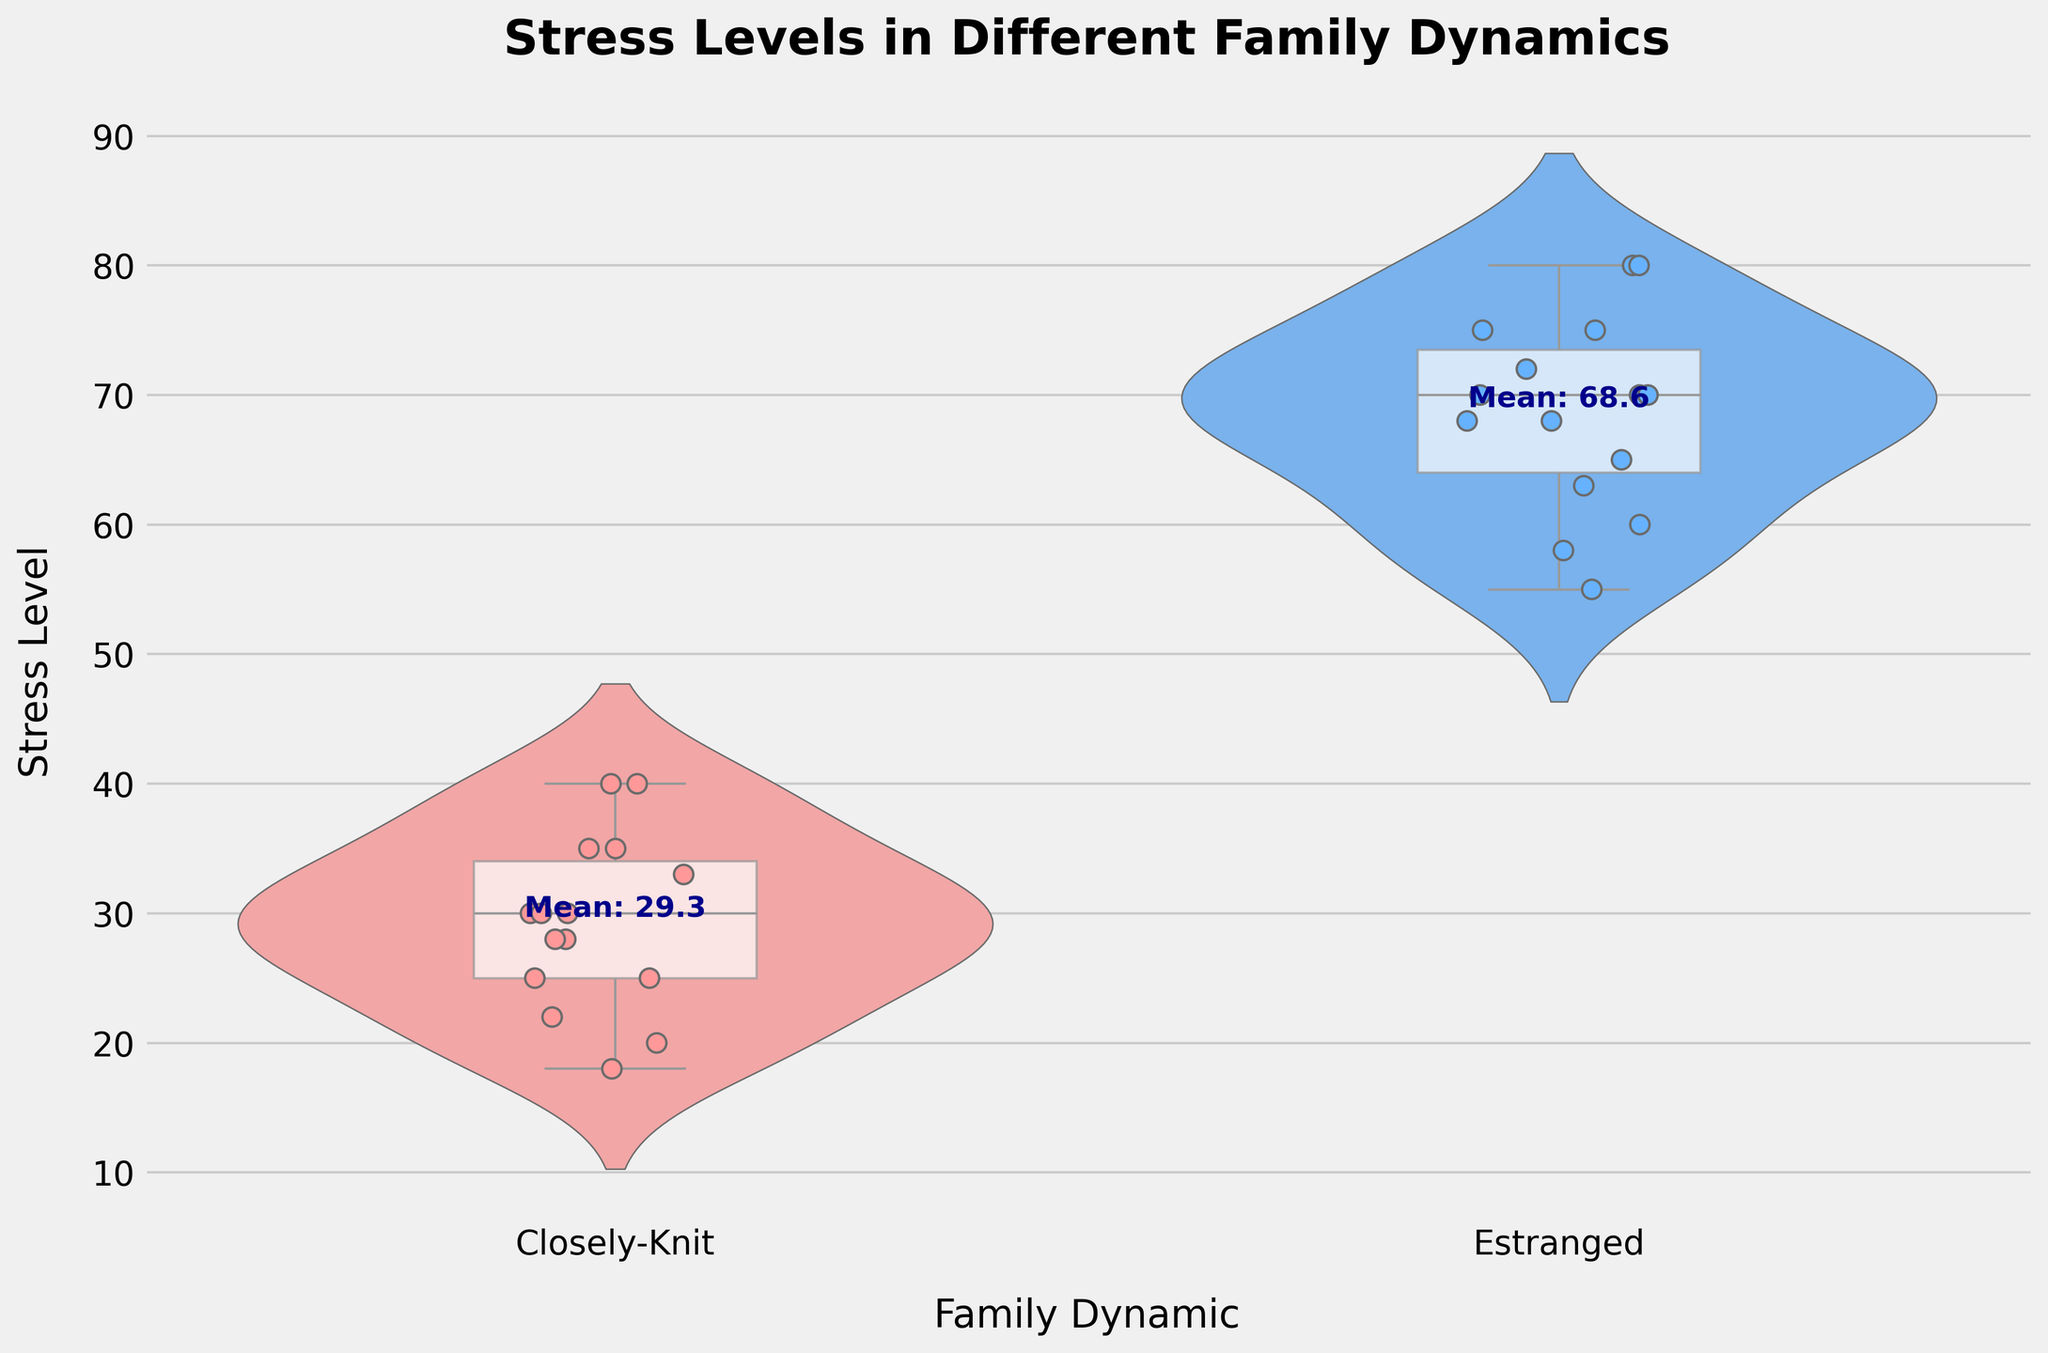What's the title of the figure? Look at the top of the figure where the title is located. The title is "Stress Levels in Different Family Dynamics"
Answer: Stress Levels in Different Family Dynamics What are the two family dynamics compared in the figure? The family dynamics are displayed along the x-axis. The two dynamics are "Closely-Knit" and "Estranged"
Answer: Closely-Knit, Estranged Which family dynamic has higher stress levels on average? The mean stress levels are indicated by text near the center of each violin plot. For the "Closely-Knit" category, the mean is lower than for the "Estranged" category
Answer: Estranged How are the stress levels distributed in closely-knit families? Observe the shape of the violin plot and the box plot overlay for closely-knit families. The violin plot shows a symmetric distribution centered around the 20s to 40s range, and the box plot indicates the same median and interquartile range
Answer: Around 20s to 40s What's the median stress level for estranged families? Look at the white line inside the box plot for estranged families in the violin plot. The median stress level is approximately in the middle of the 60s to 70s range
Answer: Around 68 Between which two ranges do the stress levels for closely-knit families mostly fall? Examine the heights of the thicker parts of the violin plot for closely-knit families. The stress levels mostly fall between 20 and 40
Answer: 20 and 40 What is a visible difference in the interquartile ranges (IQR) of stress levels between closely-knit and estranged families? The width of the box plot represents the IQR. The IQR for closely-knit families is narrower than for estranged families, indicating less variability
Answer: Closely-Knit has a narrower IQR How do stress levels for estranged families compare to closely-knit families in terms of variability? Observe the spread and the box plots of both family dynamics. Estranged families have wider distributions and larger box plots, indicating more variability in stress levels
Answer: More variability in estranged families What does the bold text indicate on the violin plot? The bold text near each violin plot indicates the mean stress level for that family dynamic
Answer: Mean stress level What can be said about the maximum stress levels in the figure? Examine the topmost points of the violin plots. The maximum stress levels are higher in estranged families than in closely-knit families
Answer: Higher in estranged families 